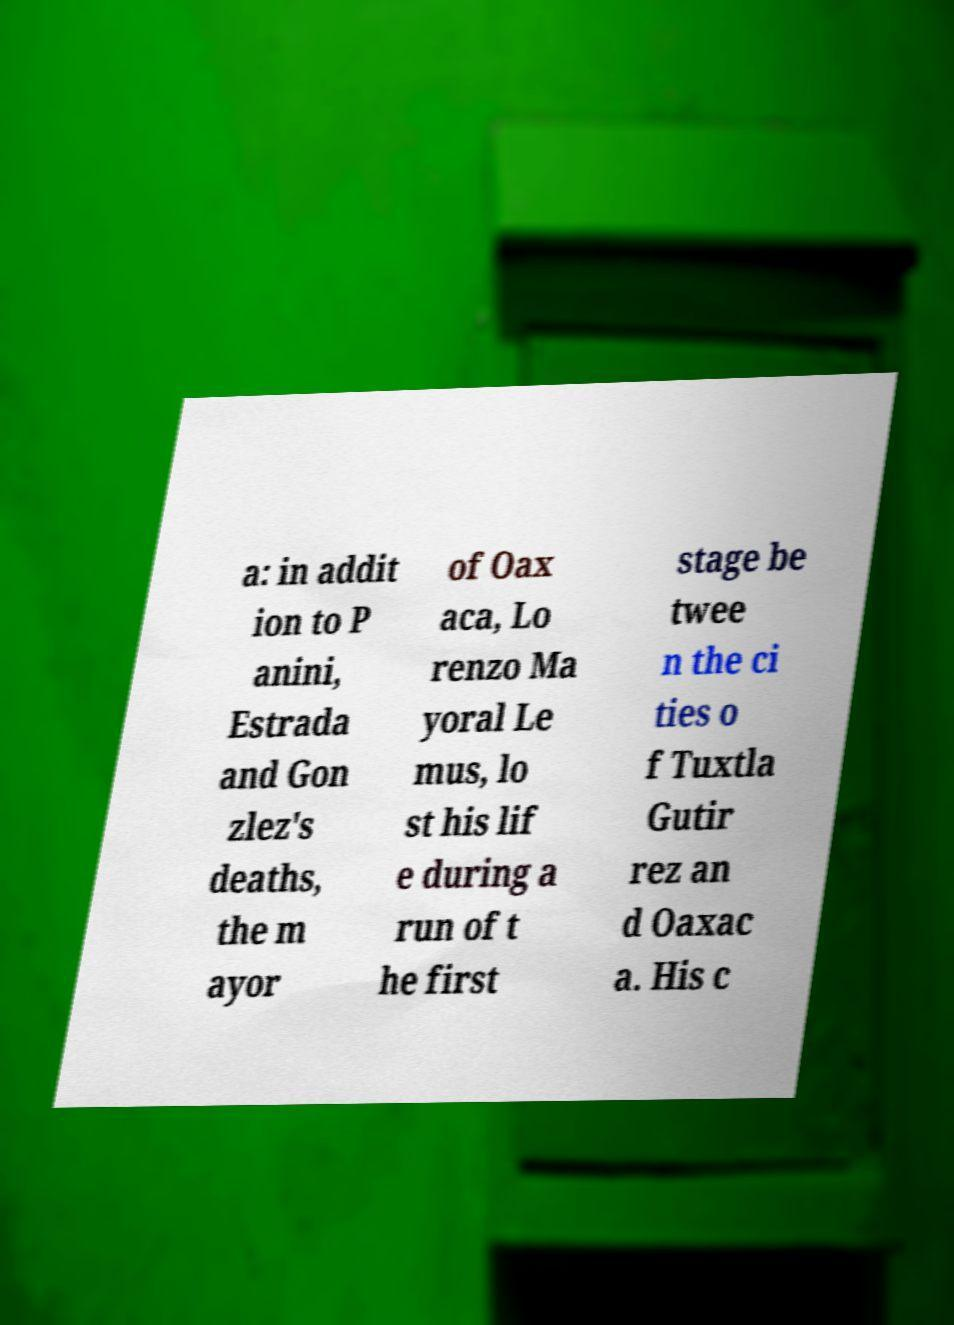Can you accurately transcribe the text from the provided image for me? a: in addit ion to P anini, Estrada and Gon zlez's deaths, the m ayor of Oax aca, Lo renzo Ma yoral Le mus, lo st his lif e during a run of t he first stage be twee n the ci ties o f Tuxtla Gutir rez an d Oaxac a. His c 